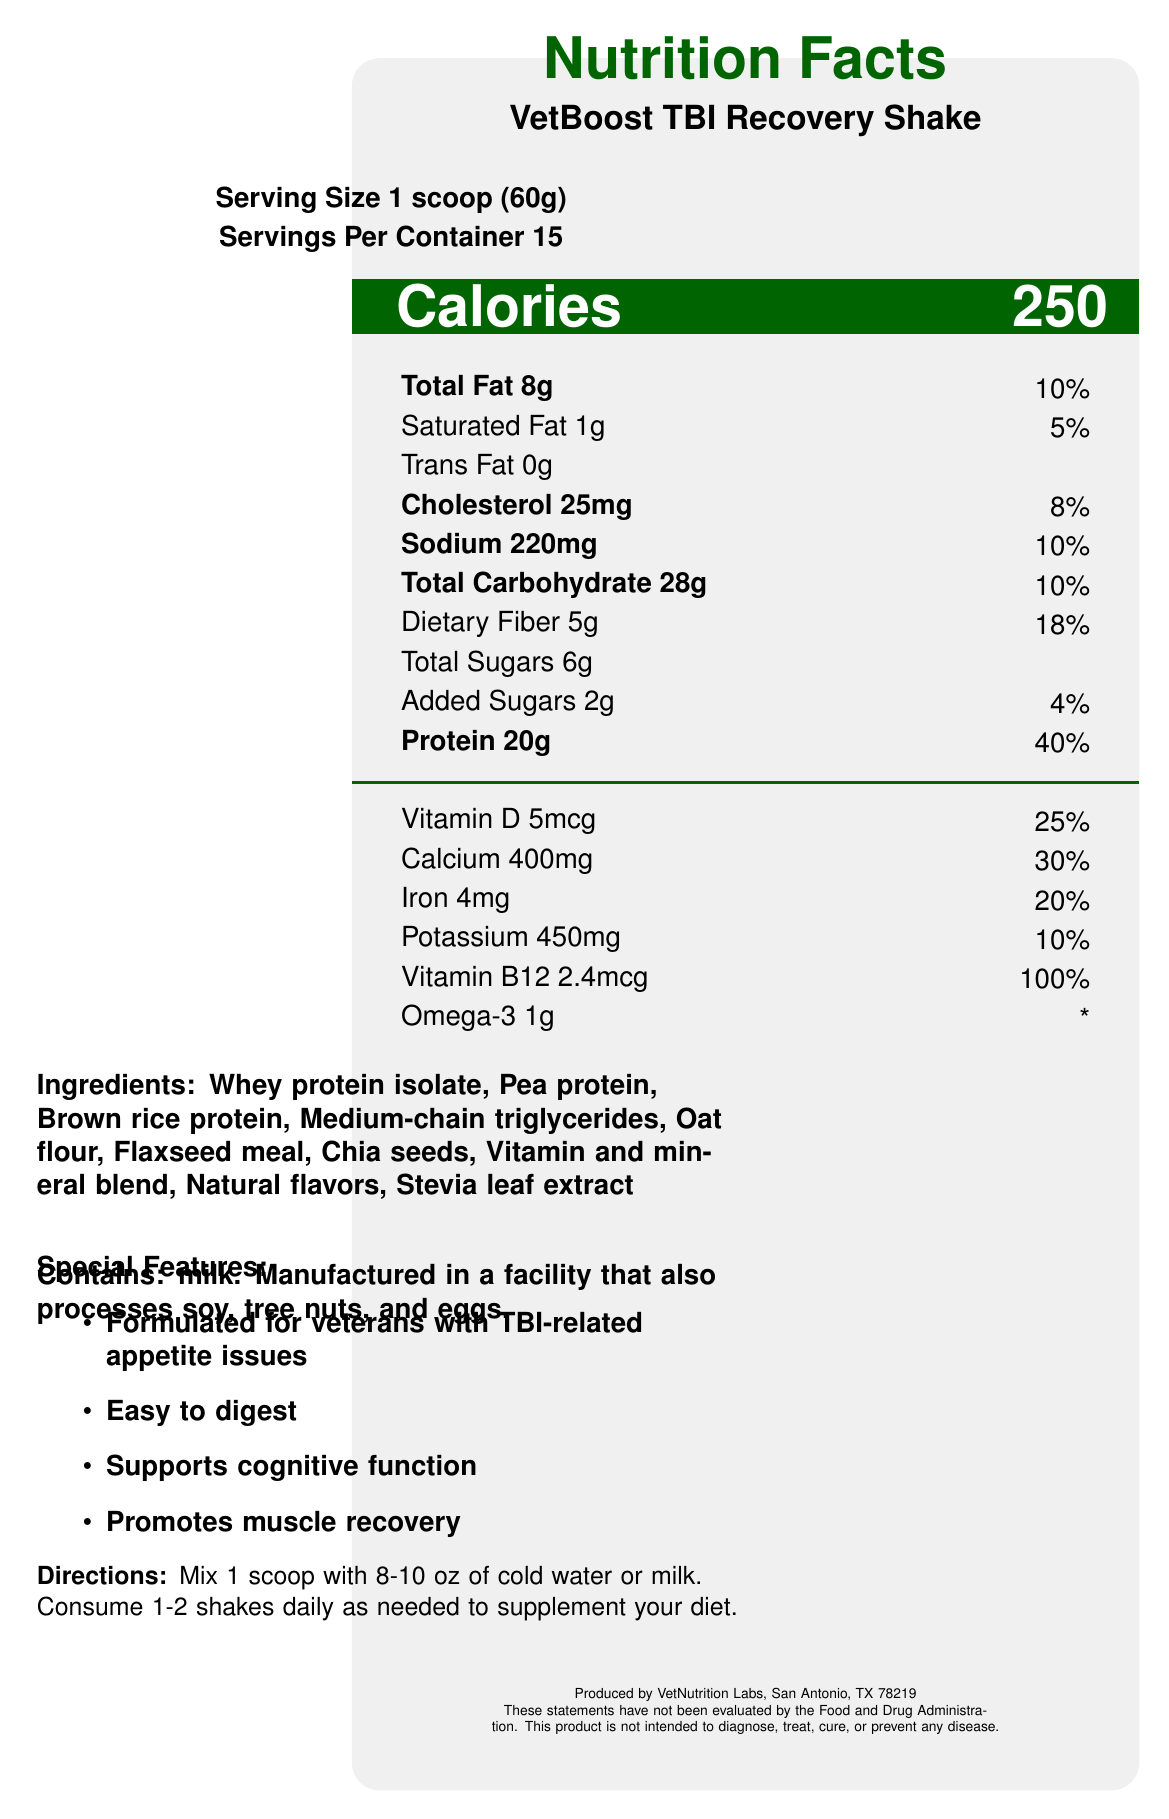what is the serving size of VetBoost TBI Recovery Shake? The serving size is explicitly stated at the beginning of the document as "Serving Size 1 scoop (60g)".
Answer: 1 scoop (60g) how many servings are in one container of the shake? The document states "Servings Per Container 15" just below the serving size information.
Answer: 15 how much protein is in one serving of the shake? The amount of protein is listed under the nutrition facts with an amount of "20g" and a daily value of "40%".
Answer: 20g what percentage of the daily value for calcium does one serving provide? The document indicates "Calcium 400mg" with a daily value of "30%" under the vitamins and minerals section.
Answer: 30% which ingredient is listed first in the ingredients list? The ingredients are listed in order of quantity used, and "Whey protein isolate" is the first ingredient mentioned.
Answer: Whey protein isolate how many calories does a serving of the shake contain? The calorie content is prominently displayed as "Calories 250" under the calorie information section.
Answer: 250 which vitamin has the highest percentage of the daily value per serving? A. Vitamin D B. Calcium C. Iron D. Vitamin B12 "Vitamin B12" provides 100% of the daily value per serving, as stated in the vitamins and minerals section.
Answer: D what is the total carbohydrate content in one serving? A. 28g B. 18g C. 10g D. 20g The total carbohydrate amount is specifically listed as "Total Carbohydrate 28g".
Answer: A is the shake easy to digest? The document mentions in the "Special Features" section that the shake is "Easy to digest."
Answer: Yes who manufactures the VetBoost TBI Recovery Shake? The manufacturer information is at the bottom of the document: "Produced by VetNutrition Labs, San Antonio, TX 78219".
Answer: VetNutrition Labs, San Antonio, TX 78219 does this product contain any added sugars? The document lists "Added Sugars 2g" under the nutrition facts section.
Answer: Yes does the label provide any information about Omega-3 content? The label lists "Omega-3 1g" although it does not provide a daily value percentage for it.
Answer: Yes what are the special features of the VetBoost TBI Recovery Shake? The special features are explicitly listed in the "Special Features" section of the document.
Answer: Formulated for veterans with TBI-related appetite issues, Easy to digest, Supports cognitive function, Promotes muscle recovery how should the shake be prepared and consumed? The instructions are clearly stated in the "Directions" section of the document.
Answer: Mix 1 scoop with 8-10 oz of cold water or milk. Consume 1-2 shakes daily as needed to supplement your diet. does this shake contain any allergens? The allergen information is provided in the document under "Contains:".
Answer: Yes, it contains milk and is manufactured in a facility that also processes soy, tree nuts, and eggs. how much potassium is in a single serving of the shake? The document lists "Potassium 450mg" with a daily value of "10%" under the vitamins and minerals section.
Answer: 450mg (10%) is this product intended to diagnose, treat, cure, or prevent any disease? The disclaimer at the bottom of the document clearly states this product is not intended to diagnose, treat, cure, or prevent any disease.
Answer: No summarize the key nutritional information on the VetBoost TBI Recovery Shake. The summary includes the most important nutritional elements of the shake, focusing on calorie content, macronutrients, and key vitamins and minerals.
Answer: The shake provides 250 calories per serving, with 8g of total fat, 1g of saturated fat, 0g of trans fat, 25mg cholesterol, 220mg sodium, 28g total carbohydrate, 5g dietary fiber, 6g total sugars including 2g added sugars, and 20g protein. It is rich in vitamins and minerals, including 100% of the daily value for vitamin B12 and 25% for vitamin D. is the flavor of the shake mentioned in the document? The document does not specify the flavor of the shake, only that it contains "Natural flavors".
Answer: Not mentioned when is it suggested to consume the shakes? This information is given in the "Directions" section of the document.
Answer: As needed to supplement your diet, 1-2 times daily. 